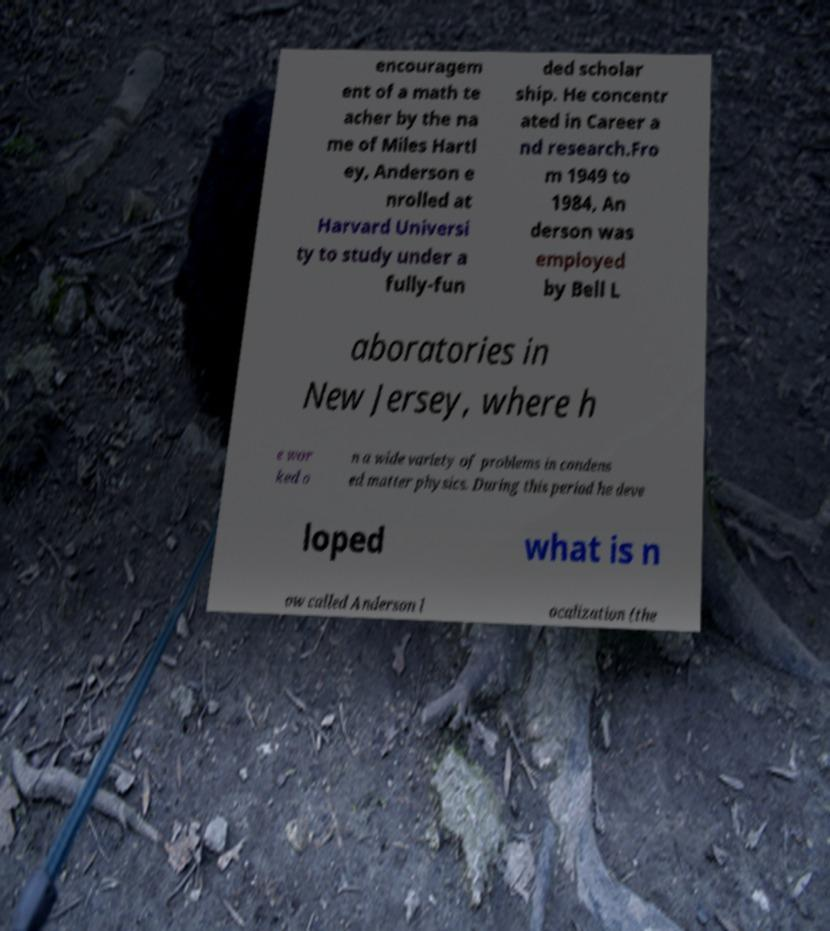I need the written content from this picture converted into text. Can you do that? encouragem ent of a math te acher by the na me of Miles Hartl ey, Anderson e nrolled at Harvard Universi ty to study under a fully-fun ded scholar ship. He concentr ated in Career a nd research.Fro m 1949 to 1984, An derson was employed by Bell L aboratories in New Jersey, where h e wor ked o n a wide variety of problems in condens ed matter physics. During this period he deve loped what is n ow called Anderson l ocalization (the 